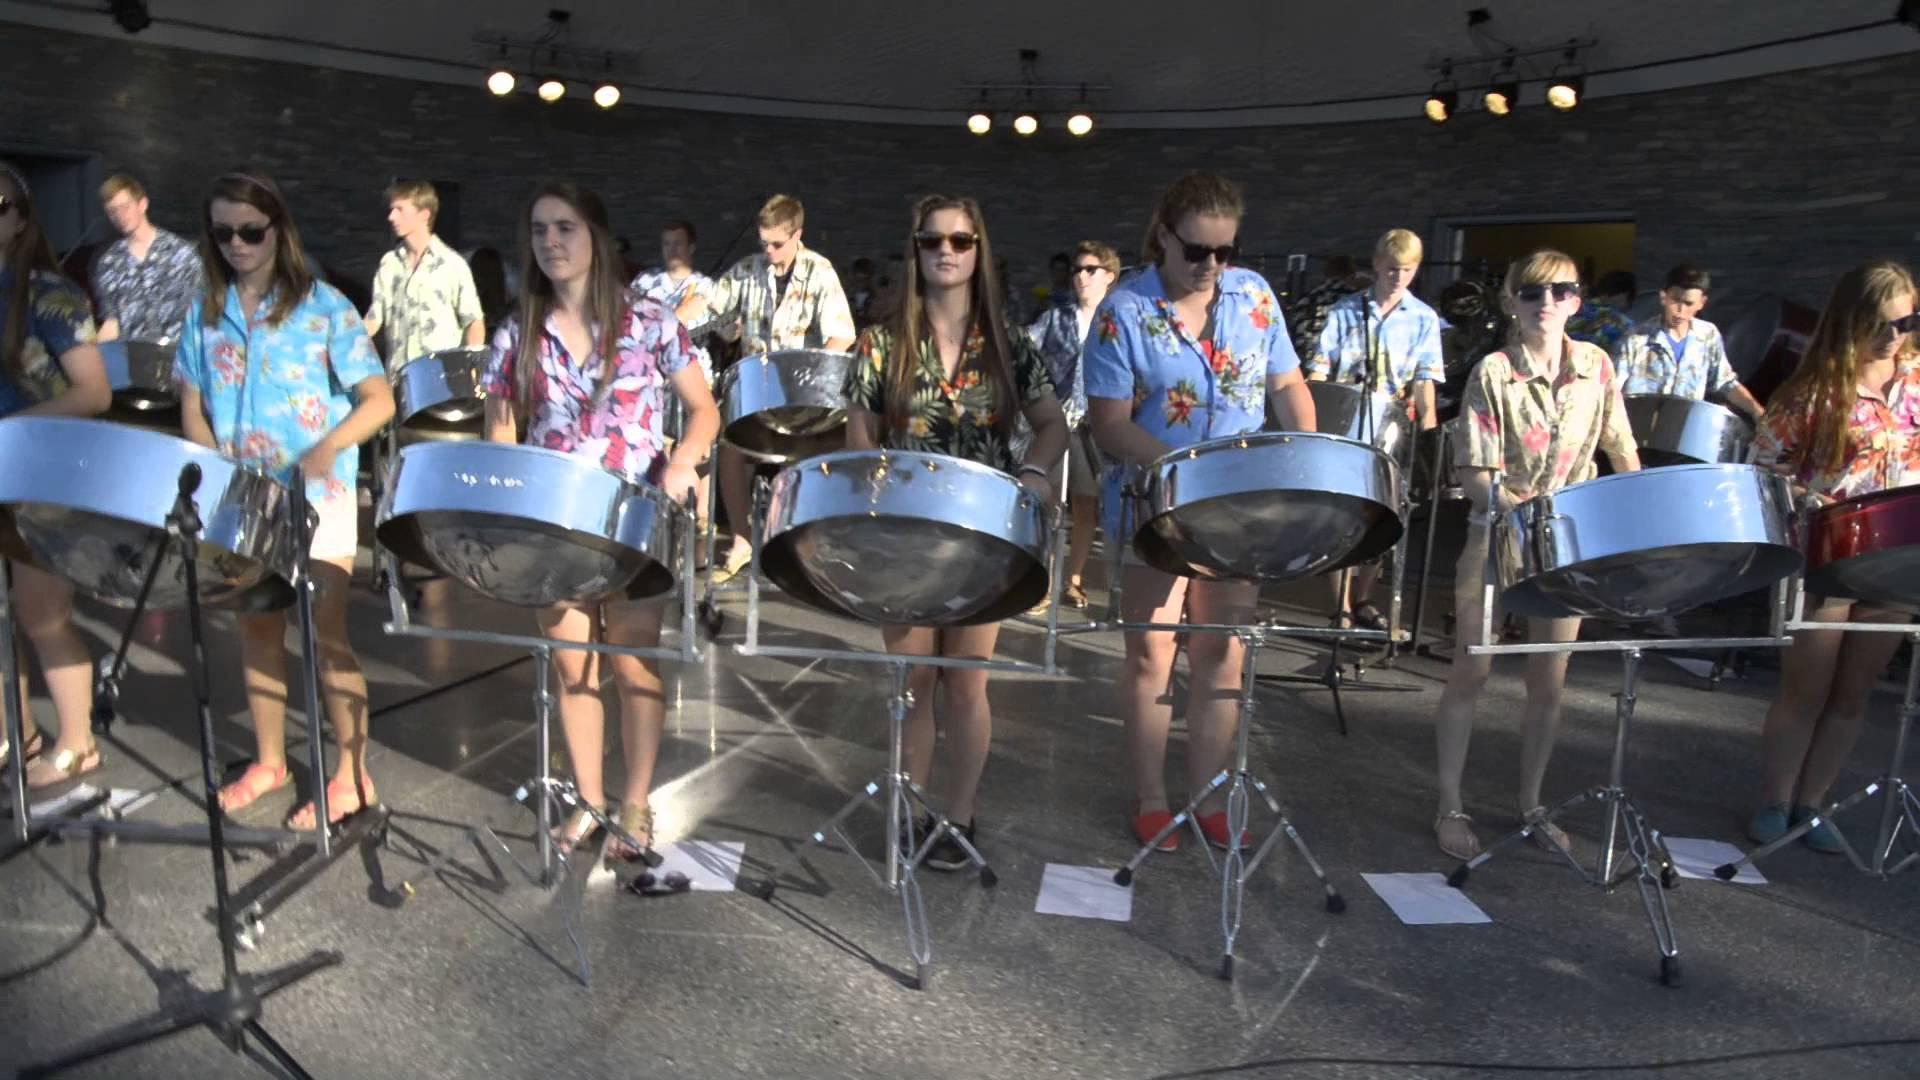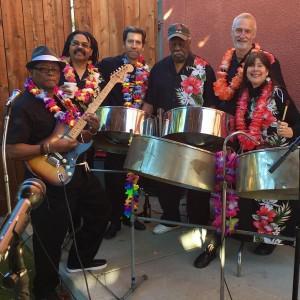The first image is the image on the left, the second image is the image on the right. Considering the images on both sides, is "The left image shows a group of musicians in black pants and violet-blue short-sleeved shirts standing in front of cylindrical drums." valid? Answer yes or no. No. The first image is the image on the left, the second image is the image on the right. Analyze the images presented: Is the assertion "All of the drummers in the image on the left are wearing purple shirts." valid? Answer yes or no. No. 